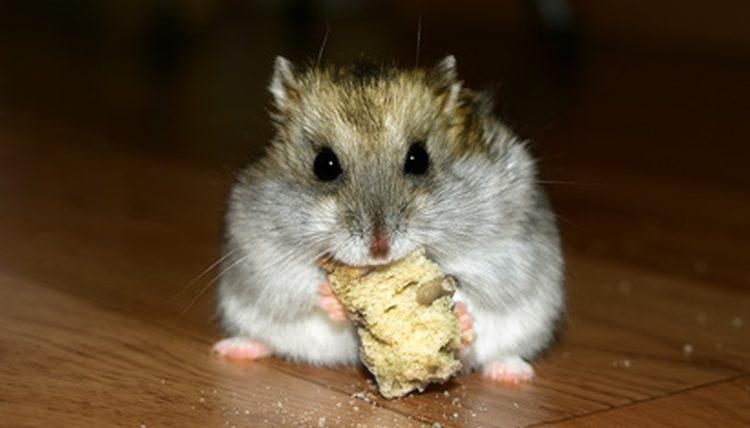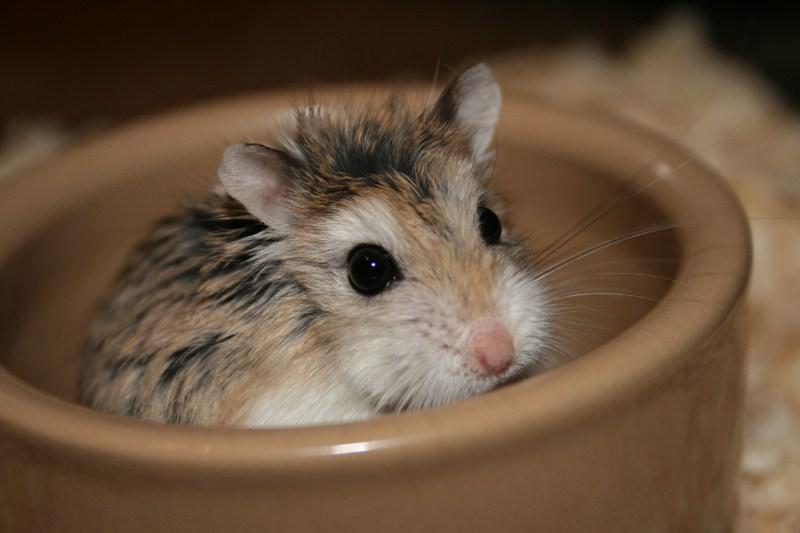The first image is the image on the left, the second image is the image on the right. Assess this claim about the two images: "one animal is on top of the other in the right side image". Correct or not? Answer yes or no. No. 